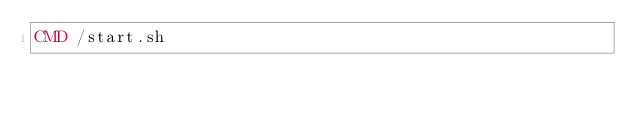Convert code to text. <code><loc_0><loc_0><loc_500><loc_500><_Dockerfile_>CMD /start.sh
</code> 